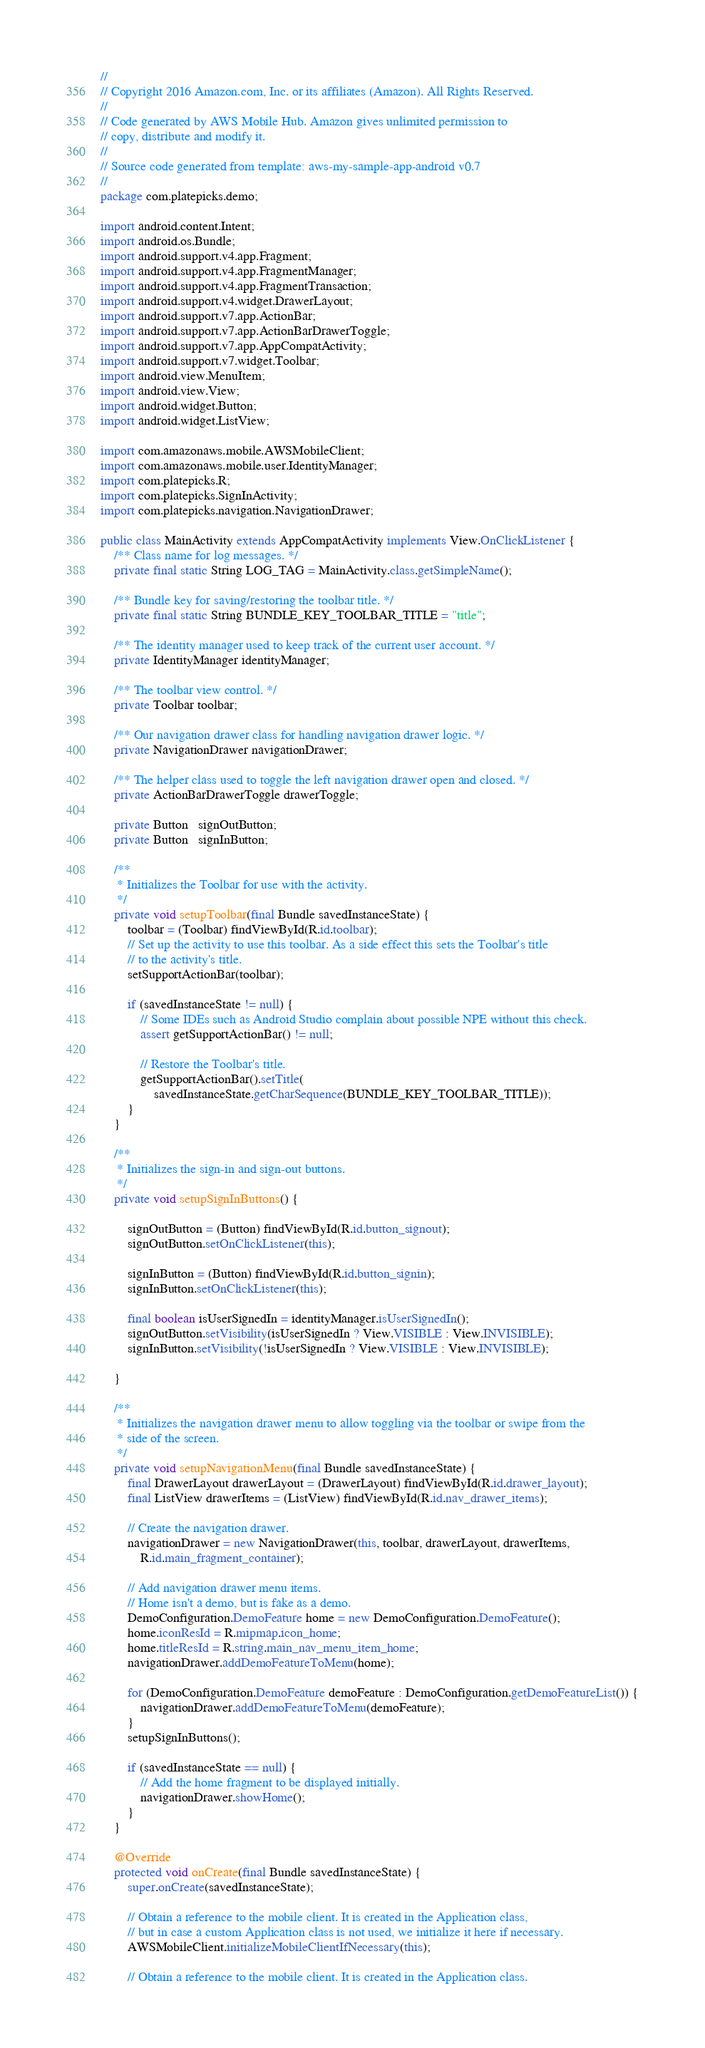Convert code to text. <code><loc_0><loc_0><loc_500><loc_500><_Java_>//
// Copyright 2016 Amazon.com, Inc. or its affiliates (Amazon). All Rights Reserved.
//
// Code generated by AWS Mobile Hub. Amazon gives unlimited permission to 
// copy, distribute and modify it.
//
// Source code generated from template: aws-my-sample-app-android v0.7
//
package com.platepicks.demo;

import android.content.Intent;
import android.os.Bundle;
import android.support.v4.app.Fragment;
import android.support.v4.app.FragmentManager;
import android.support.v4.app.FragmentTransaction;
import android.support.v4.widget.DrawerLayout;
import android.support.v7.app.ActionBar;
import android.support.v7.app.ActionBarDrawerToggle;
import android.support.v7.app.AppCompatActivity;
import android.support.v7.widget.Toolbar;
import android.view.MenuItem;
import android.view.View;
import android.widget.Button;
import android.widget.ListView;

import com.amazonaws.mobile.AWSMobileClient;
import com.amazonaws.mobile.user.IdentityManager;
import com.platepicks.R;
import com.platepicks.SignInActivity;
import com.platepicks.navigation.NavigationDrawer;

public class MainActivity extends AppCompatActivity implements View.OnClickListener {
    /** Class name for log messages. */
    private final static String LOG_TAG = MainActivity.class.getSimpleName();

    /** Bundle key for saving/restoring the toolbar title. */
    private final static String BUNDLE_KEY_TOOLBAR_TITLE = "title";

    /** The identity manager used to keep track of the current user account. */
    private IdentityManager identityManager;

    /** The toolbar view control. */
    private Toolbar toolbar;

    /** Our navigation drawer class for handling navigation drawer logic. */
    private NavigationDrawer navigationDrawer;

    /** The helper class used to toggle the left navigation drawer open and closed. */
    private ActionBarDrawerToggle drawerToggle;

    private Button   signOutButton;
    private Button   signInButton;

    /**
     * Initializes the Toolbar for use with the activity.
     */
    private void setupToolbar(final Bundle savedInstanceState) {
        toolbar = (Toolbar) findViewById(R.id.toolbar);
        // Set up the activity to use this toolbar. As a side effect this sets the Toolbar's title
        // to the activity's title.
        setSupportActionBar(toolbar);

        if (savedInstanceState != null) {
            // Some IDEs such as Android Studio complain about possible NPE without this check.
            assert getSupportActionBar() != null;

            // Restore the Toolbar's title.
            getSupportActionBar().setTitle(
                savedInstanceState.getCharSequence(BUNDLE_KEY_TOOLBAR_TITLE));
        }
    }

    /**
     * Initializes the sign-in and sign-out buttons.
     */
    private void setupSignInButtons() {

        signOutButton = (Button) findViewById(R.id.button_signout);
        signOutButton.setOnClickListener(this);

        signInButton = (Button) findViewById(R.id.button_signin);
        signInButton.setOnClickListener(this);

        final boolean isUserSignedIn = identityManager.isUserSignedIn();
        signOutButton.setVisibility(isUserSignedIn ? View.VISIBLE : View.INVISIBLE);
        signInButton.setVisibility(!isUserSignedIn ? View.VISIBLE : View.INVISIBLE);

    }

    /**
     * Initializes the navigation drawer menu to allow toggling via the toolbar or swipe from the
     * side of the screen.
     */
    private void setupNavigationMenu(final Bundle savedInstanceState) {
        final DrawerLayout drawerLayout = (DrawerLayout) findViewById(R.id.drawer_layout);
        final ListView drawerItems = (ListView) findViewById(R.id.nav_drawer_items);

        // Create the navigation drawer.
        navigationDrawer = new NavigationDrawer(this, toolbar, drawerLayout, drawerItems,
            R.id.main_fragment_container);

        // Add navigation drawer menu items.
        // Home isn't a demo, but is fake as a demo.
        DemoConfiguration.DemoFeature home = new DemoConfiguration.DemoFeature();
        home.iconResId = R.mipmap.icon_home;
        home.titleResId = R.string.main_nav_menu_item_home;
        navigationDrawer.addDemoFeatureToMenu(home);

        for (DemoConfiguration.DemoFeature demoFeature : DemoConfiguration.getDemoFeatureList()) {
            navigationDrawer.addDemoFeatureToMenu(demoFeature);
        }
        setupSignInButtons();

        if (savedInstanceState == null) {
            // Add the home fragment to be displayed initially.
            navigationDrawer.showHome();
        }
    }

    @Override
    protected void onCreate(final Bundle savedInstanceState) {
        super.onCreate(savedInstanceState);

        // Obtain a reference to the mobile client. It is created in the Application class,
        // but in case a custom Application class is not used, we initialize it here if necessary.
        AWSMobileClient.initializeMobileClientIfNecessary(this);

        // Obtain a reference to the mobile client. It is created in the Application class.</code> 